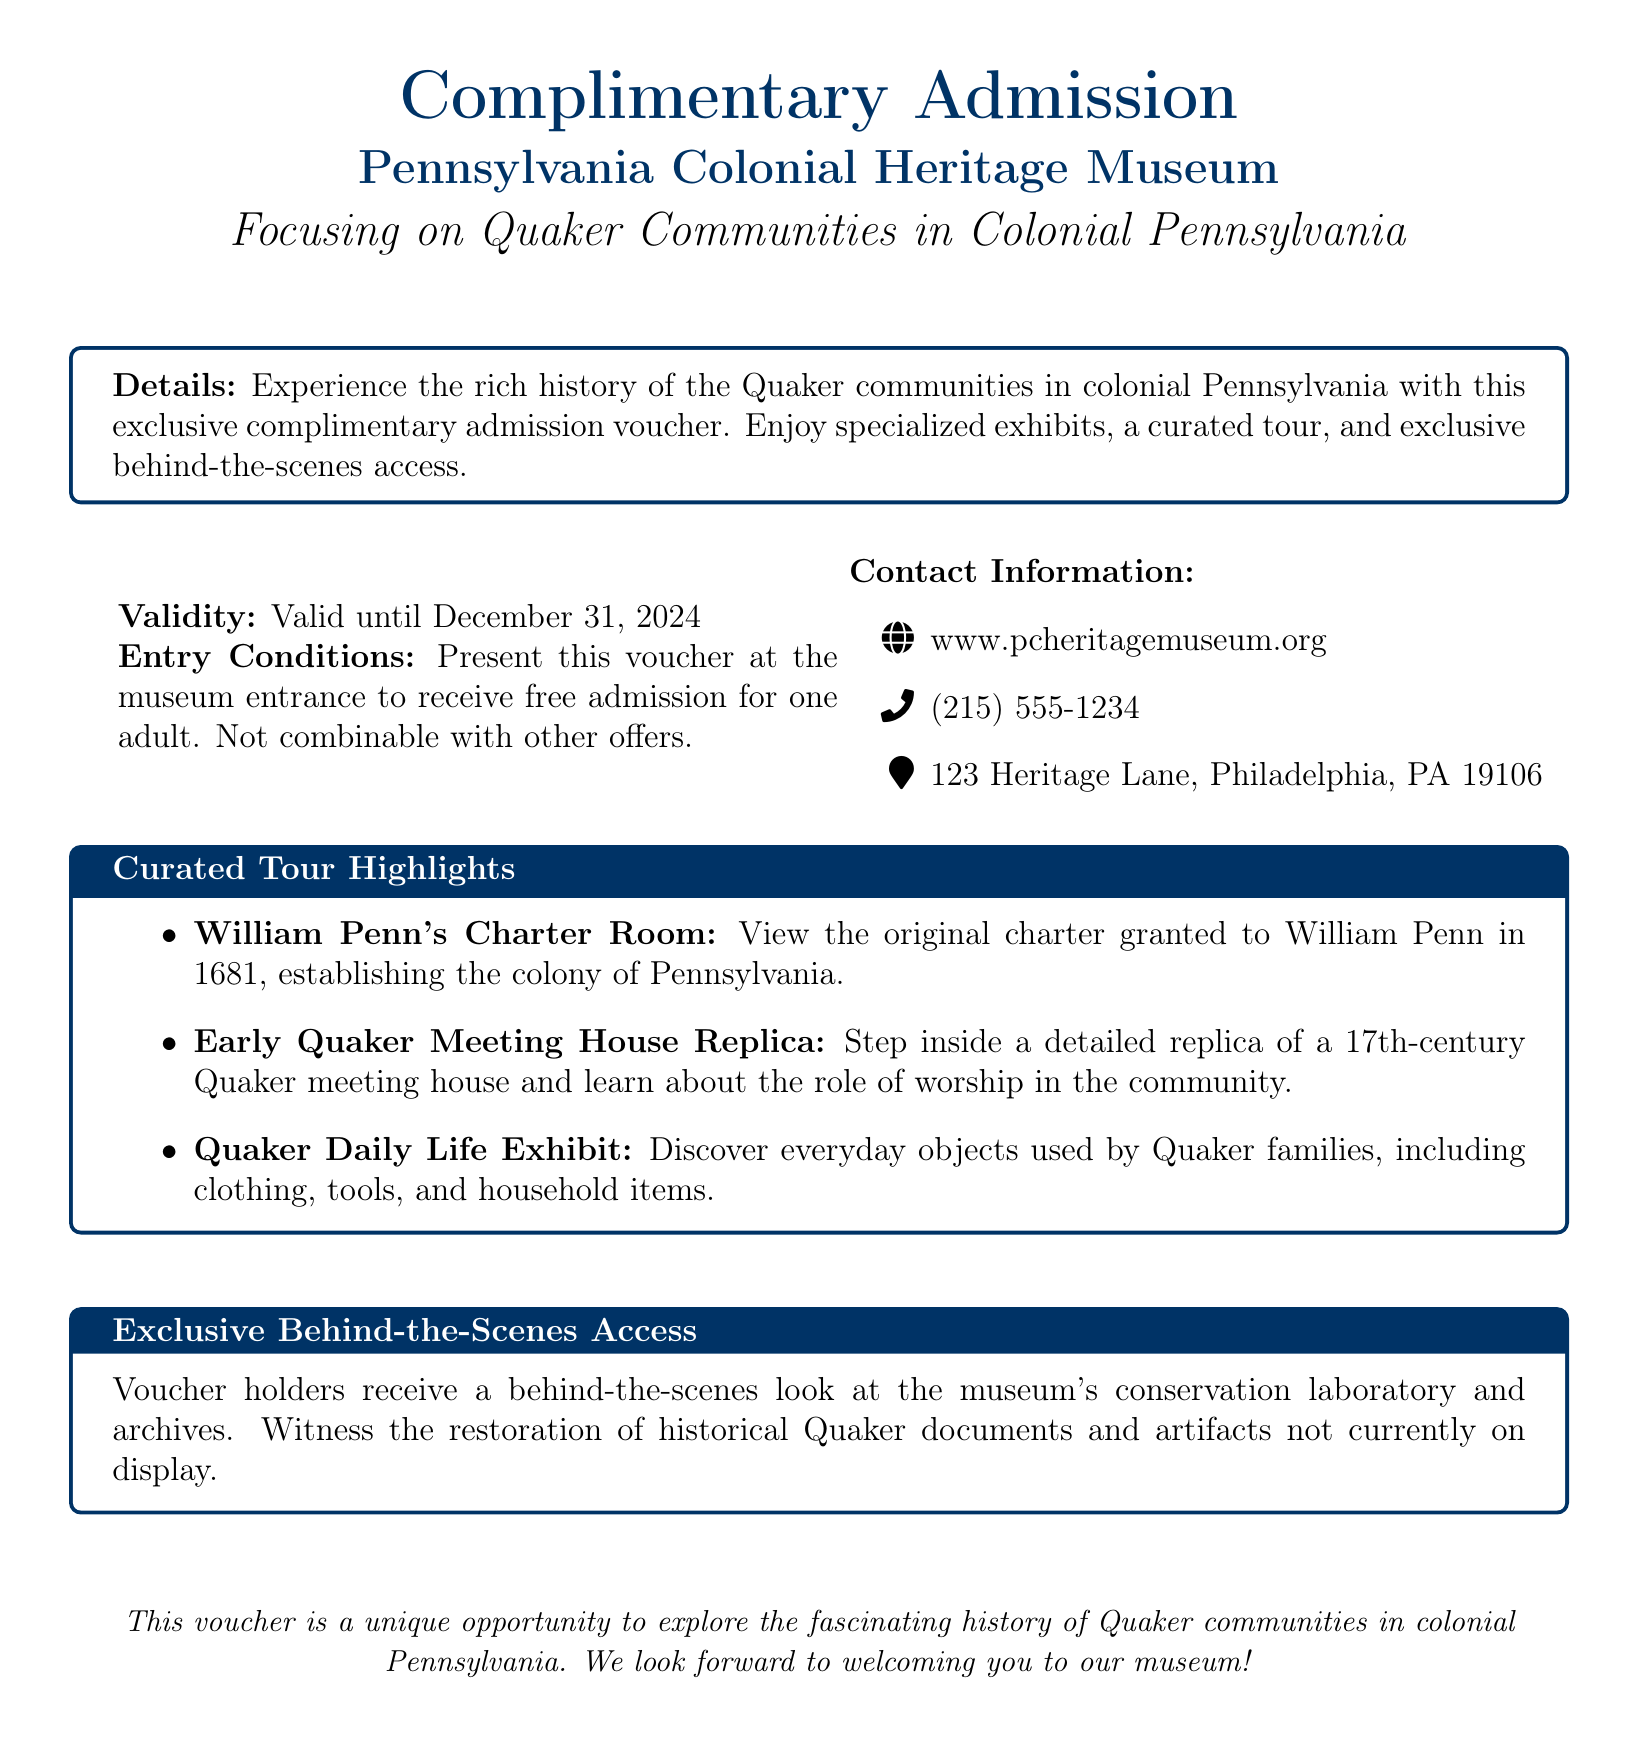What museum does the voucher pertain to? The voucher specifically mentions the Pennsylvania Colonial Heritage Museum as the location for complimentary admission.
Answer: Pennsylvania Colonial Heritage Museum What is the focus of the museum? The document states that the museum has a special focus on Quaker communities in colonial Pennsylvania.
Answer: Quaker communities What is the validity period of the voucher? The document explicitly states that the voucher is valid until December 31, 2024.
Answer: December 31, 2024 How many persons can use the voucher for free entry? It is mentioned that the voucher allows free admission for one adult, indicating the limit on its use.
Answer: one adult What can voucher holders access in the museum's conservation laboratory? The document indicates that voucher holders can witness the restoration of historical Quaker documents and artifacts in the conservation laboratory.
Answer: restoration of historical Quaker documents What type of replica can visitors see at the museum? The voucher highlights an Early Quaker Meeting House Replica, which is a major attraction mentioned.
Answer: Early Quaker Meeting House Replica Where is the museum located? The document provides a specific address for the museum as 123 Heritage Lane, Philadelphia, PA 19106.
Answer: 123 Heritage Lane, Philadelphia, PA 19106 Is the voucher combinable with other offers? According to the document, the voucher specifically states that it is not combinable with other offers.
Answer: Not combinable 